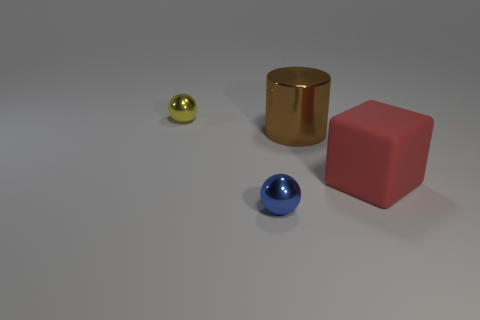Is there a light source indicated in the image, and how does it affect the appearance of the objects? Yes, there appears to be a light source, though not directly visible in the image. Its presence is evident through the shadows cast by the objects and the highlights, most notably on the metallic surfaces of the gold cylinder and blue sphere, which reflect the light, creating a sense of depth and texture. 